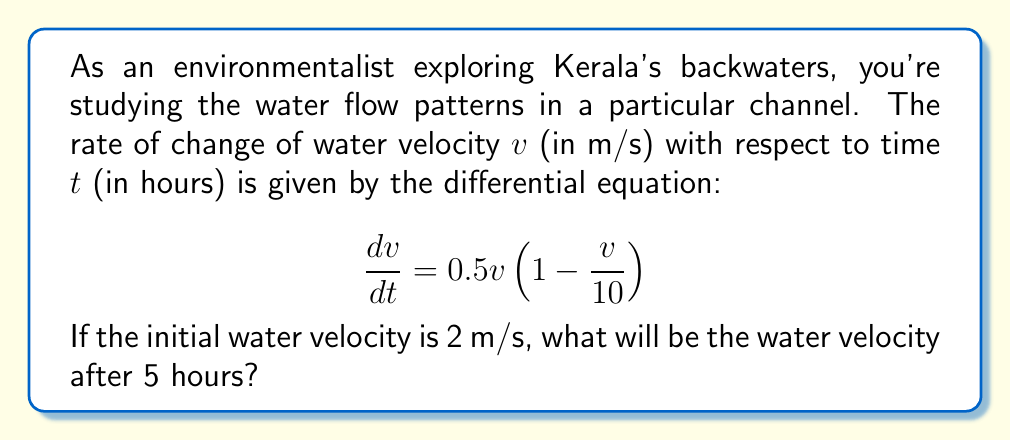Solve this math problem. To solve this problem, we need to use the given differential equation and initial condition. Let's approach this step-by-step:

1) The given differential equation is a logistic growth model:

   $$\frac{dv}{dt} = 0.5v(1 - \frac{v}{10})$$

2) This equation has the general form:

   $$\frac{dv}{dt} = rv(1 - \frac{v}{K})$$

   where $r = 0.5$ and $K = 10$.

3) The solution to this logistic equation is:

   $$v(t) = \frac{K}{1 + (\frac{K}{v_0} - 1)e^{-rt}}$$

   where $v_0$ is the initial velocity.

4) Substituting the known values:
   $K = 10$, $r = 0.5$, $v_0 = 2$, and $t = 5$

5) Let's calculate:

   $$v(5) = \frac{10}{1 + (\frac{10}{2} - 1)e^{-0.5(5)}}$$

6) Simplify:

   $$v(5) = \frac{10}{1 + 4e^{-2.5}}$$

7) Calculate $e^{-2.5} \approx 0.0821$

8) Substitute:

   $$v(5) = \frac{10}{1 + 4(0.0821)} = \frac{10}{1.3284}$$

9) Calculate the final result:

   $$v(5) \approx 7.53 \text{ m/s}$$
Answer: 7.53 m/s 